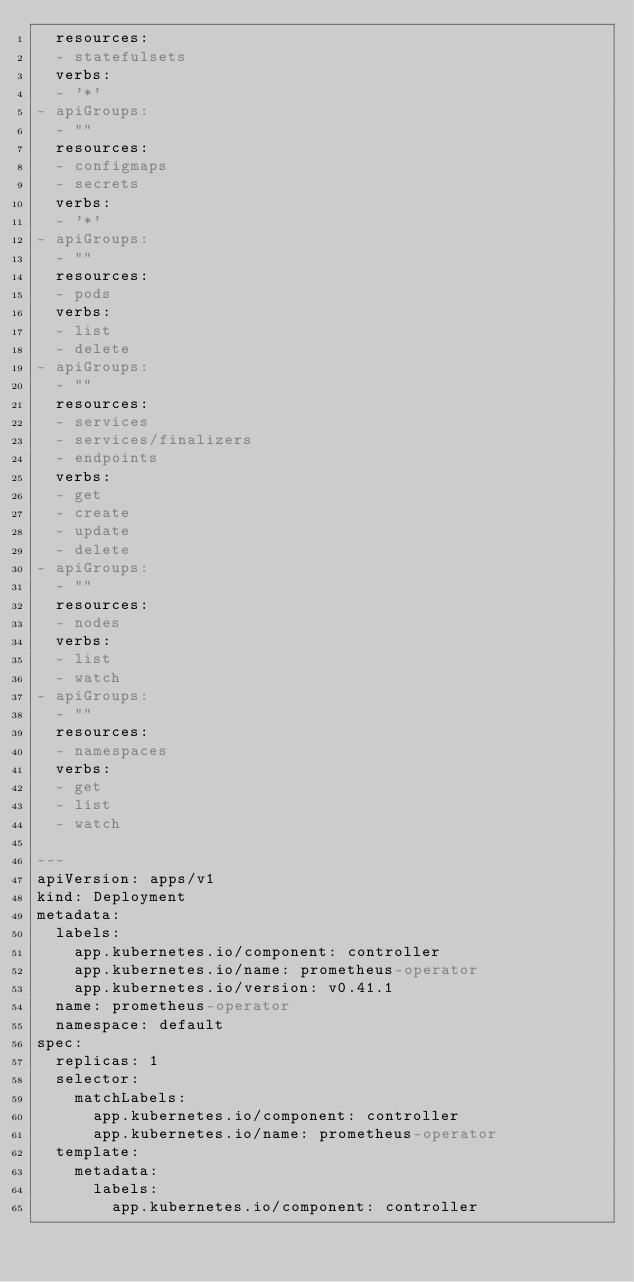Convert code to text. <code><loc_0><loc_0><loc_500><loc_500><_YAML_>  resources:
  - statefulsets
  verbs:
  - '*'
- apiGroups:
  - ""
  resources:
  - configmaps
  - secrets
  verbs:
  - '*'
- apiGroups:
  - ""
  resources:
  - pods
  verbs:
  - list
  - delete
- apiGroups:
  - ""
  resources:
  - services
  - services/finalizers
  - endpoints
  verbs:
  - get
  - create
  - update
  - delete
- apiGroups:
  - ""
  resources:
  - nodes
  verbs:
  - list
  - watch
- apiGroups:
  - ""
  resources:
  - namespaces
  verbs:
  - get
  - list
  - watch

---
apiVersion: apps/v1
kind: Deployment
metadata:
  labels:
    app.kubernetes.io/component: controller
    app.kubernetes.io/name: prometheus-operator
    app.kubernetes.io/version: v0.41.1
  name: prometheus-operator
  namespace: default
spec:
  replicas: 1
  selector:
    matchLabels:
      app.kubernetes.io/component: controller
      app.kubernetes.io/name: prometheus-operator
  template:
    metadata:
      labels:
        app.kubernetes.io/component: controller</code> 